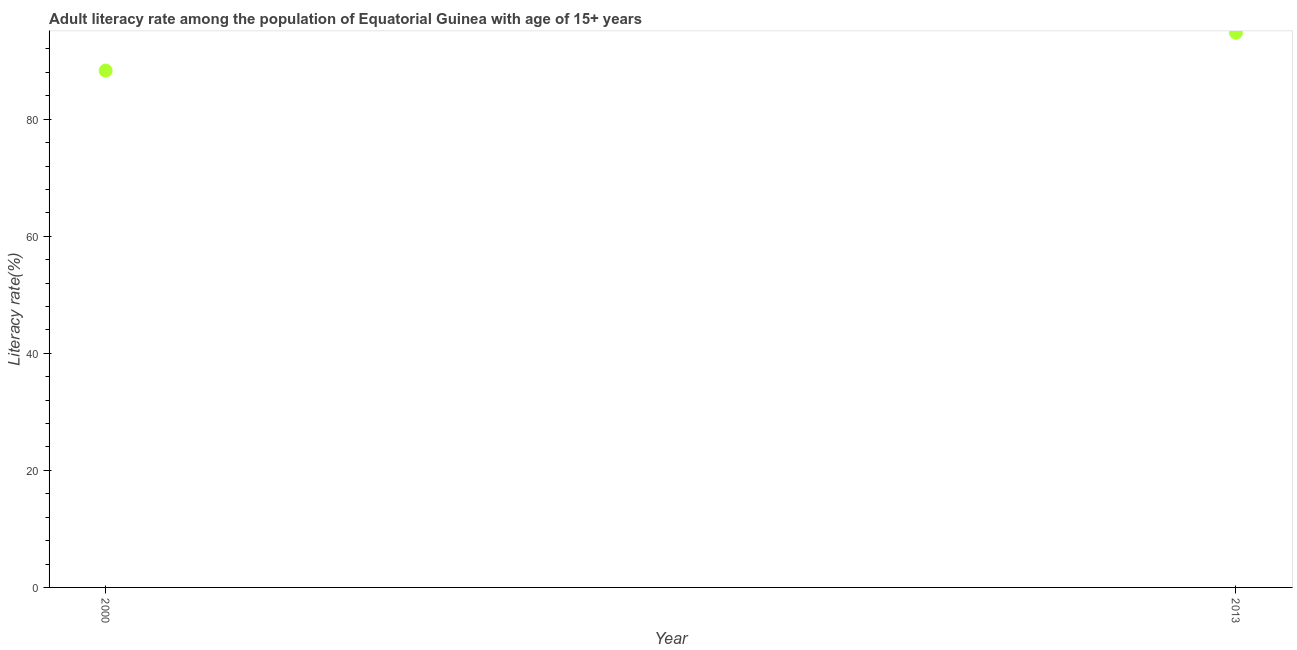What is the adult literacy rate in 2013?
Offer a very short reply. 94.77. Across all years, what is the maximum adult literacy rate?
Ensure brevity in your answer.  94.77. Across all years, what is the minimum adult literacy rate?
Keep it short and to the point. 88.31. In which year was the adult literacy rate minimum?
Give a very brief answer. 2000. What is the sum of the adult literacy rate?
Keep it short and to the point. 183.08. What is the difference between the adult literacy rate in 2000 and 2013?
Offer a very short reply. -6.47. What is the average adult literacy rate per year?
Offer a very short reply. 91.54. What is the median adult literacy rate?
Provide a short and direct response. 91.54. In how many years, is the adult literacy rate greater than 56 %?
Your response must be concise. 2. What is the ratio of the adult literacy rate in 2000 to that in 2013?
Make the answer very short. 0.93. Is the adult literacy rate in 2000 less than that in 2013?
Your answer should be compact. Yes. Does the adult literacy rate monotonically increase over the years?
Make the answer very short. Yes. What is the difference between two consecutive major ticks on the Y-axis?
Your answer should be very brief. 20. Are the values on the major ticks of Y-axis written in scientific E-notation?
Provide a succinct answer. No. Does the graph contain any zero values?
Your answer should be compact. No. Does the graph contain grids?
Your answer should be compact. No. What is the title of the graph?
Make the answer very short. Adult literacy rate among the population of Equatorial Guinea with age of 15+ years. What is the label or title of the Y-axis?
Offer a very short reply. Literacy rate(%). What is the Literacy rate(%) in 2000?
Provide a short and direct response. 88.31. What is the Literacy rate(%) in 2013?
Offer a terse response. 94.77. What is the difference between the Literacy rate(%) in 2000 and 2013?
Offer a terse response. -6.47. What is the ratio of the Literacy rate(%) in 2000 to that in 2013?
Offer a very short reply. 0.93. 